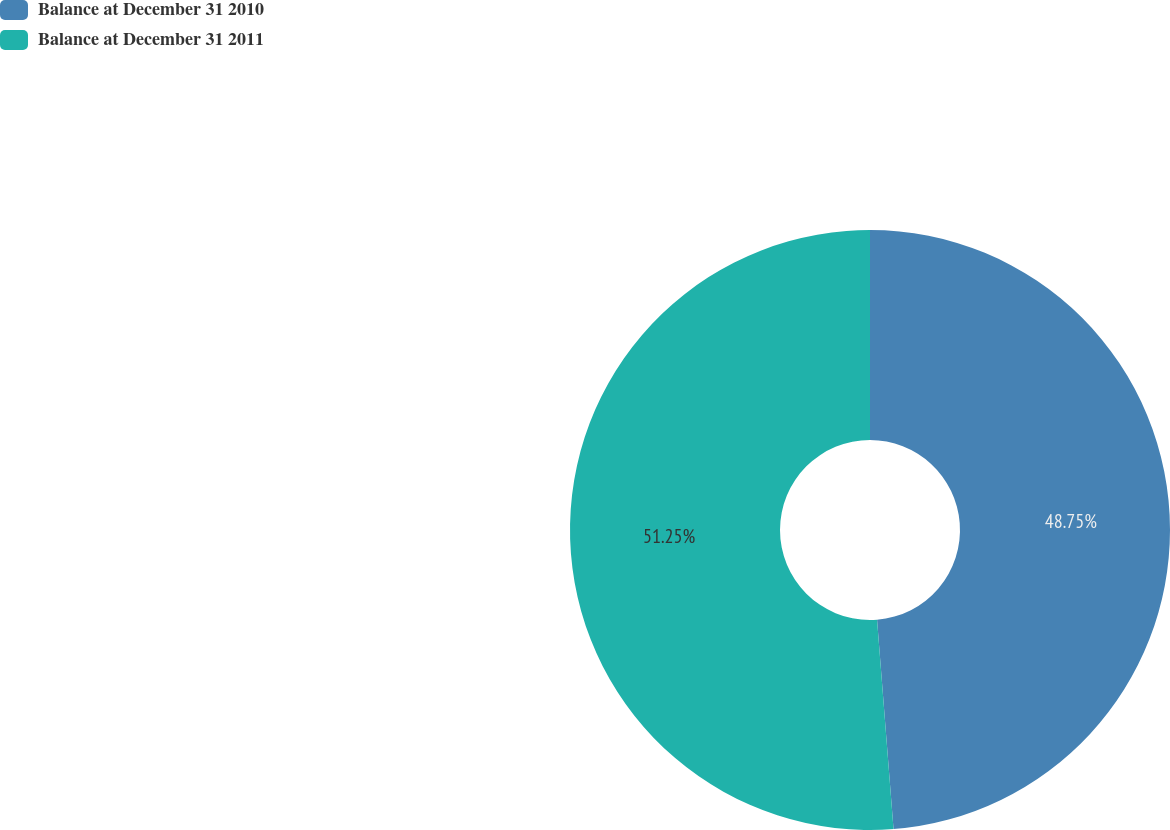<chart> <loc_0><loc_0><loc_500><loc_500><pie_chart><fcel>Balance at December 31 2010<fcel>Balance at December 31 2011<nl><fcel>48.75%<fcel>51.25%<nl></chart> 